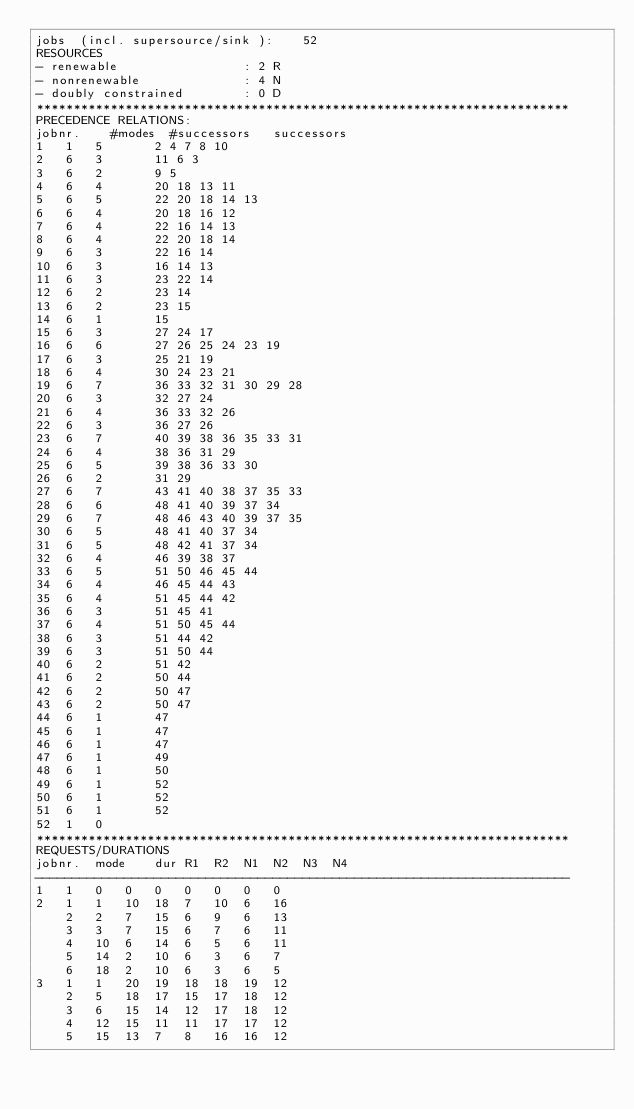<code> <loc_0><loc_0><loc_500><loc_500><_ObjectiveC_>jobs  (incl. supersource/sink ):	52
RESOURCES
- renewable                 : 2 R
- nonrenewable              : 4 N
- doubly constrained        : 0 D
************************************************************************
PRECEDENCE RELATIONS:
jobnr.    #modes  #successors   successors
1	1	5		2 4 7 8 10 
2	6	3		11 6 3 
3	6	2		9 5 
4	6	4		20 18 13 11 
5	6	5		22 20 18 14 13 
6	6	4		20 18 16 12 
7	6	4		22 16 14 13 
8	6	4		22 20 18 14 
9	6	3		22 16 14 
10	6	3		16 14 13 
11	6	3		23 22 14 
12	6	2		23 14 
13	6	2		23 15 
14	6	1		15 
15	6	3		27 24 17 
16	6	6		27 26 25 24 23 19 
17	6	3		25 21 19 
18	6	4		30 24 23 21 
19	6	7		36 33 32 31 30 29 28 
20	6	3		32 27 24 
21	6	4		36 33 32 26 
22	6	3		36 27 26 
23	6	7		40 39 38 36 35 33 31 
24	6	4		38 36 31 29 
25	6	5		39 38 36 33 30 
26	6	2		31 29 
27	6	7		43 41 40 38 37 35 33 
28	6	6		48 41 40 39 37 34 
29	6	7		48 46 43 40 39 37 35 
30	6	5		48 41 40 37 34 
31	6	5		48 42 41 37 34 
32	6	4		46 39 38 37 
33	6	5		51 50 46 45 44 
34	6	4		46 45 44 43 
35	6	4		51 45 44 42 
36	6	3		51 45 41 
37	6	4		51 50 45 44 
38	6	3		51 44 42 
39	6	3		51 50 44 
40	6	2		51 42 
41	6	2		50 44 
42	6	2		50 47 
43	6	2		50 47 
44	6	1		47 
45	6	1		47 
46	6	1		47 
47	6	1		49 
48	6	1		50 
49	6	1		52 
50	6	1		52 
51	6	1		52 
52	1	0		
************************************************************************
REQUESTS/DURATIONS
jobnr.	mode	dur	R1	R2	N1	N2	N3	N4	
------------------------------------------------------------------------
1	1	0	0	0	0	0	0	0	
2	1	1	10	18	7	10	6	16	
	2	2	7	15	6	9	6	13	
	3	3	7	15	6	7	6	11	
	4	10	6	14	6	5	6	11	
	5	14	2	10	6	3	6	7	
	6	18	2	10	6	3	6	5	
3	1	1	20	19	18	18	19	12	
	2	5	18	17	15	17	18	12	
	3	6	15	14	12	17	18	12	
	4	12	15	11	11	17	17	12	
	5	15	13	7	8	16	16	12	</code> 